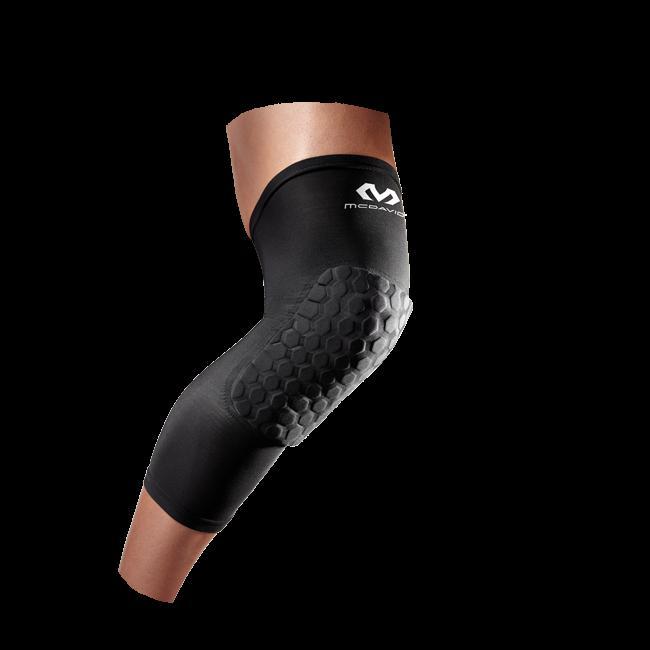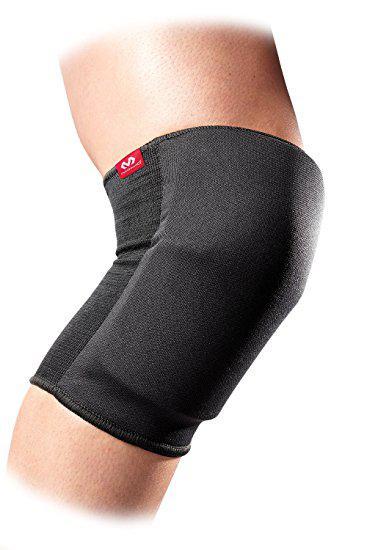The first image is the image on the left, the second image is the image on the right. Evaluate the accuracy of this statement regarding the images: "one of the images is one a black background". Is it true? Answer yes or no. Yes. The first image is the image on the left, the second image is the image on the right. Examine the images to the left and right. Is the description "Exactly two knee braces are positioned on legs to show their proper use." accurate? Answer yes or no. Yes. 